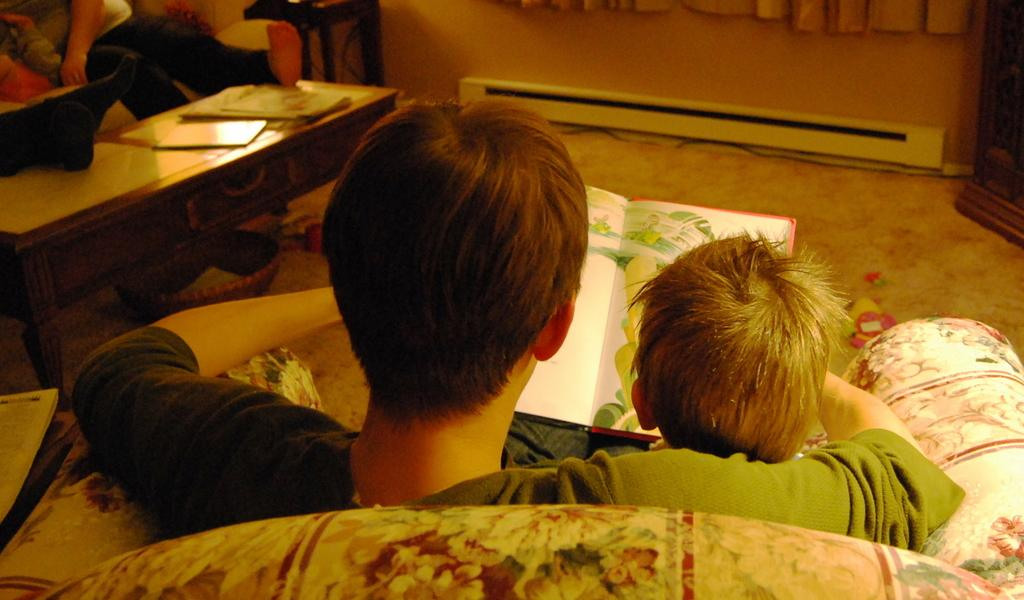Who is present in the image? There is a man and a kid in the image. What are the man and the kid doing in the image? The man and the kid are sitting on a chair in the image. What is the man holding in his hand? The man is holding a book in his hand. What can be seen on the table in the image? There are books on the table in the image. How many people are sitting in the image? There are two people sitting in the image, the man and the kid. What type of song can be heard playing in the background of the image? There is no indication of any music or sound in the image, so it is not possible to determine what song might be playing. 